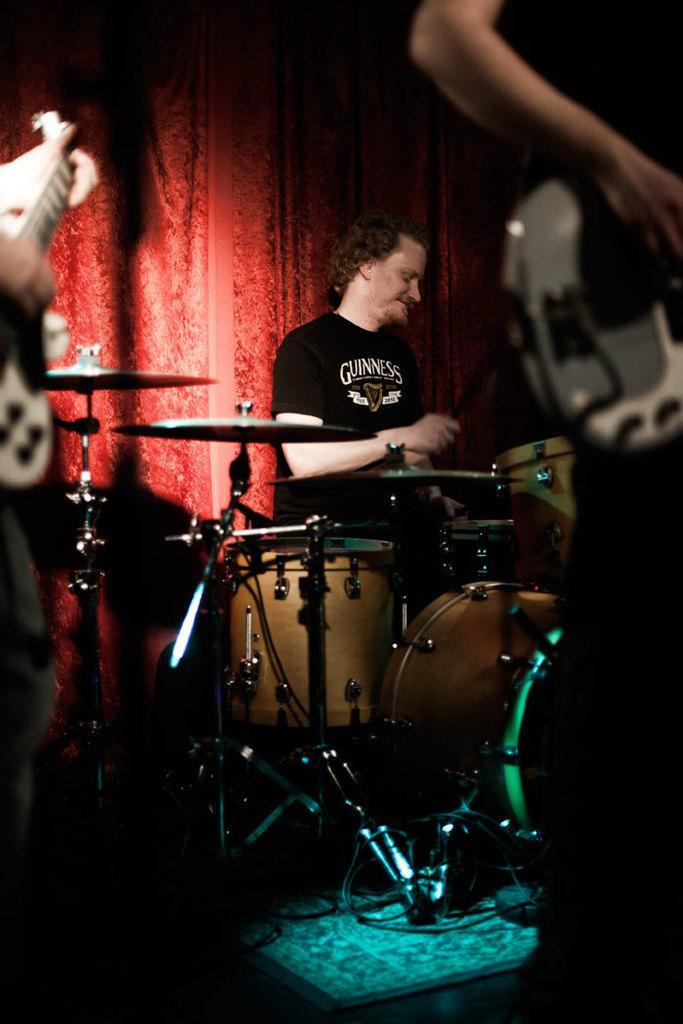Please provide a concise description of this image. In the center of the image we can see a person sitting in front of musical instruments placed on the ground. In the foreground we can see two persons holding guitars in their hands. 